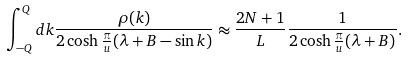Convert formula to latex. <formula><loc_0><loc_0><loc_500><loc_500>\int ^ { Q } _ { - Q } d k \frac { \rho ( k ) } { 2 \cosh \frac { \pi } { u } ( \lambda + B - \sin k ) } \approx \frac { 2 N + 1 } { L } \frac { 1 } { 2 \cosh \frac { \pi } { u } ( \lambda + B ) } .</formula> 